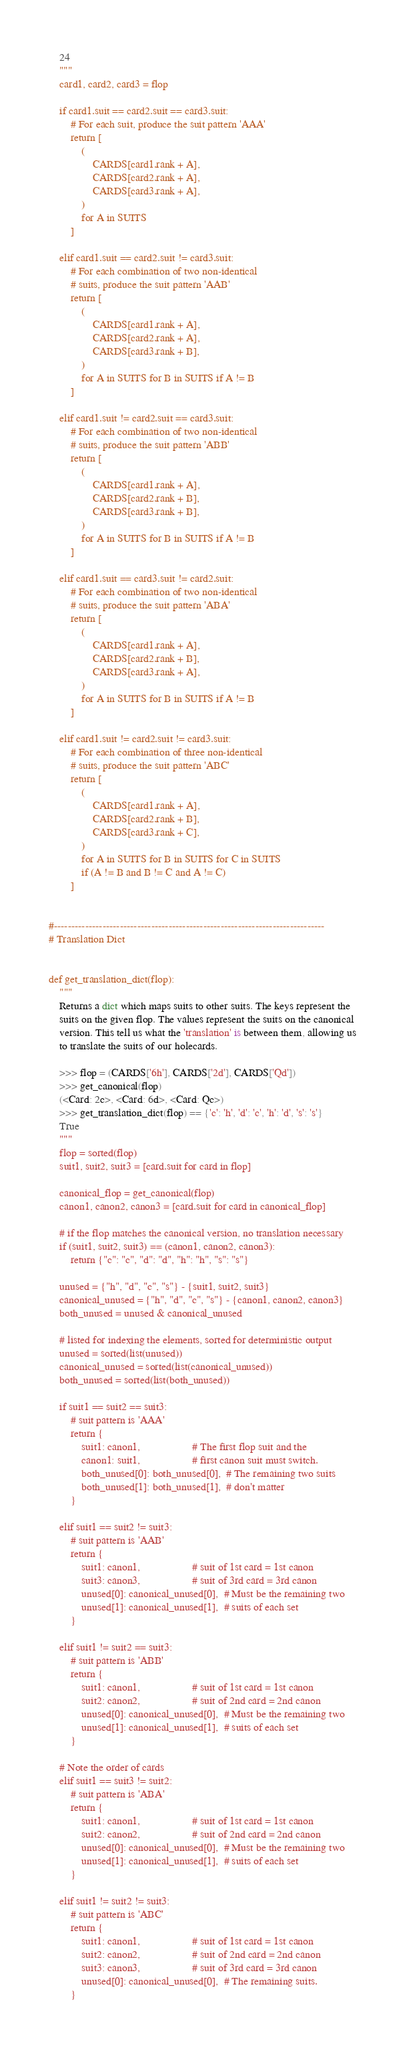<code> <loc_0><loc_0><loc_500><loc_500><_Python_>    24
    """
    card1, card2, card3 = flop

    if card1.suit == card2.suit == card3.suit:
        # For each suit, produce the suit pattern 'AAA'
        return [
            (
                CARDS[card1.rank + A],
                CARDS[card2.rank + A],
                CARDS[card3.rank + A],
            )
            for A in SUITS
        ]

    elif card1.suit == card2.suit != card3.suit:
        # For each combination of two non-identical
        # suits, produce the suit pattern 'AAB'
        return [
            (
                CARDS[card1.rank + A],
                CARDS[card2.rank + A],
                CARDS[card3.rank + B],
            )
            for A in SUITS for B in SUITS if A != B
        ]

    elif card1.suit != card2.suit == card3.suit:
        # For each combination of two non-identical
        # suits, produce the suit pattern 'ABB'
        return [
            (
                CARDS[card1.rank + A],
                CARDS[card2.rank + B],
                CARDS[card3.rank + B],
            )
            for A in SUITS for B in SUITS if A != B
        ]

    elif card1.suit == card3.suit != card2.suit:
        # For each combination of two non-identical
        # suits, produce the suit pattern 'ABA'
        return [
            (
                CARDS[card1.rank + A],
                CARDS[card2.rank + B],
                CARDS[card3.rank + A],
            )
            for A in SUITS for B in SUITS if A != B
        ]

    elif card1.suit != card2.suit != card3.suit:
        # For each combination of three non-identical
        # suits, produce the suit pattern 'ABC'
        return [
            (
                CARDS[card1.rank + A],
                CARDS[card2.rank + B],
                CARDS[card3.rank + C],
            )
            for A in SUITS for B in SUITS for C in SUITS
            if (A != B and B != C and A != C)
        ]


#------------------------------------------------------------------------------
# Translation Dict


def get_translation_dict(flop):
    """
    Returns a dict which maps suits to other suits. The keys represent the
    suits on the given flop. The values represent the suits on the canonical
    version. This tell us what the 'translation' is between them, allowing us
    to translate the suits of our holecards.

    >>> flop = (CARDS['6h'], CARDS['2d'], CARDS['Qd'])
    >>> get_canonical(flop)
    (<Card: 2c>, <Card: 6d>, <Card: Qc>)
    >>> get_translation_dict(flop) == {'c': 'h', 'd': 'c', 'h': 'd', 's': 's'}
    True
    """
    flop = sorted(flop)
    suit1, suit2, suit3 = [card.suit for card in flop]

    canonical_flop = get_canonical(flop)
    canon1, canon2, canon3 = [card.suit for card in canonical_flop]

    # if the flop matches the canonical version, no translation necessary
    if (suit1, suit2, suit3) == (canon1, canon2, canon3):
        return {"c": "c", "d": "d", "h": "h", "s": "s"}

    unused = {"h", "d", "c", "s"} - {suit1, suit2, suit3}
    canonical_unused = {"h", "d", "c", "s"} - {canon1, canon2, canon3}
    both_unused = unused & canonical_unused

    # listed for indexing the elements, sorted for deterministic output
    unused = sorted(list(unused))
    canonical_unused = sorted(list(canonical_unused))
    both_unused = sorted(list(both_unused))

    if suit1 == suit2 == suit3:
        # suit pattern is 'AAA'
        return {
            suit1: canon1,                   # The first flop suit and the
            canon1: suit1,                   # first canon suit must switch.
            both_unused[0]: both_unused[0],  # The remaining two suits
            both_unused[1]: both_unused[1],  # don't matter
        }

    elif suit1 == suit2 != suit3:
        # suit pattern is 'AAB'
        return {
            suit1: canon1,                   # suit of 1st card = 1st canon
            suit3: canon3,                   # suit of 3rd card = 3rd canon
            unused[0]: canonical_unused[0],  # Must be the remaining two
            unused[1]: canonical_unused[1],  # suits of each set
        }

    elif suit1 != suit2 == suit3:
        # suit pattern is 'ABB'
        return {
            suit1: canon1,                   # suit of 1st card = 1st canon
            suit2: canon2,                   # suit of 2nd card = 2nd canon
            unused[0]: canonical_unused[0],  # Must be the remaining two
            unused[1]: canonical_unused[1],  # suits of each set
        }

    # Note the order of cards
    elif suit1 == suit3 != suit2:
        # suit pattern is 'ABA'
        return {
            suit1: canon1,                   # suit of 1st card = 1st canon
            suit2: canon2,                   # suit of 2nd card = 2nd canon
            unused[0]: canonical_unused[0],  # Must be the remaining two
            unused[1]: canonical_unused[1],  # suits of each set
        }

    elif suit1 != suit2 != suit3:
        # suit pattern is 'ABC'
        return {
            suit1: canon1,                   # suit of 1st card = 1st canon
            suit2: canon2,                   # suit of 2nd card = 2nd canon
            suit3: canon3,                   # suit of 3rd card = 3rd canon
            unused[0]: canonical_unused[0],  # The remaining suits.
        }
</code> 